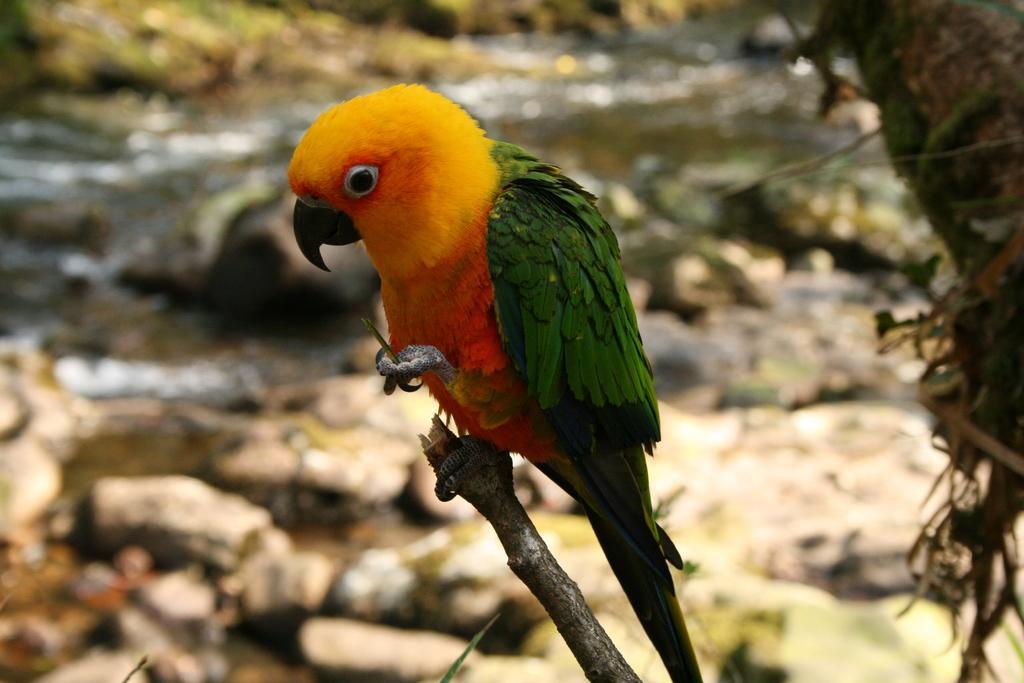How would you summarize this image in a sentence or two? At the bottom of the image there is a stem with parrot which is in yellow and green color is standing. Behind the parrot there are stones and water. And it is a blur image in the background. 